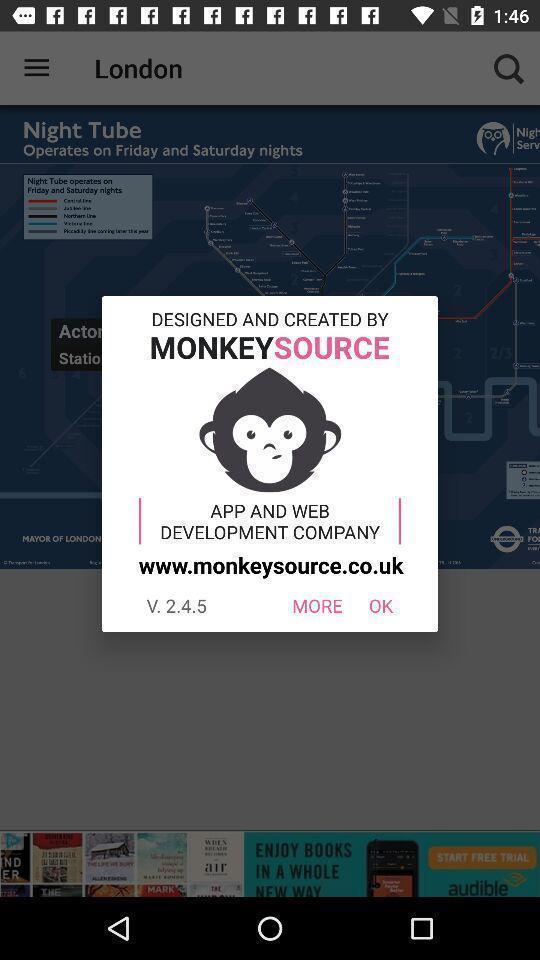Describe the content in this image. Pop-up for options more and ok on mapping app. 